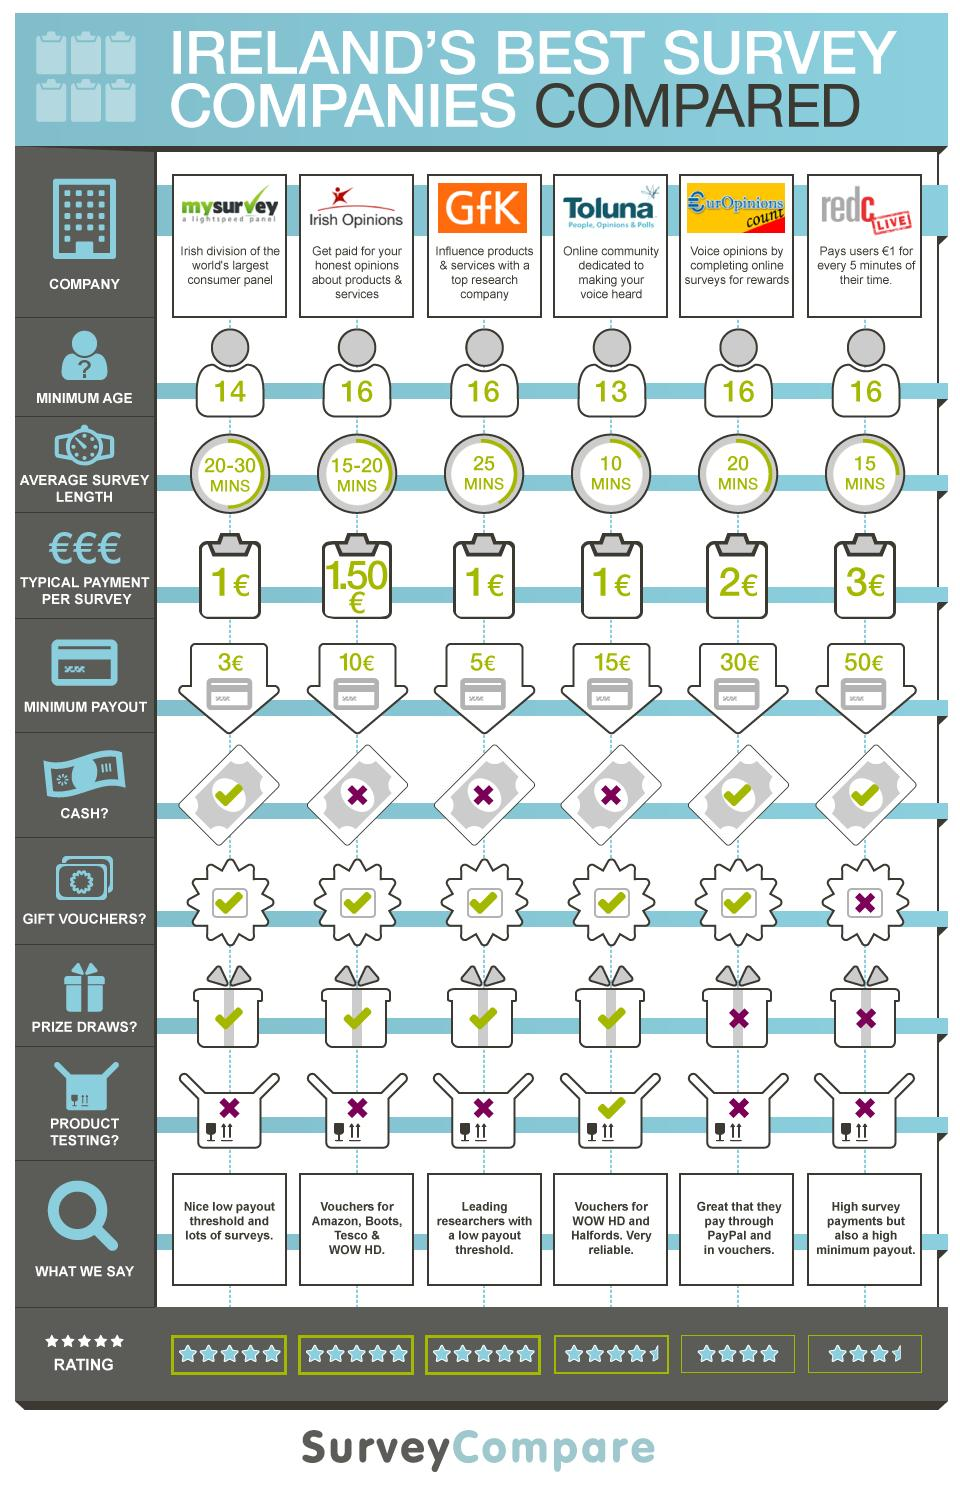Identify some key points in this picture. The minimum age required to attend the survey of GfK is 16 years old. MySurvey has the largest consumer panel in the world. According to the survey conducted by the "Europinions count" company, the rating is 4. The survey company that provides Amazon vouchers is Irish Opinions. The company "Irish Opinions" pays 1.50 euro for each of its surveys. 